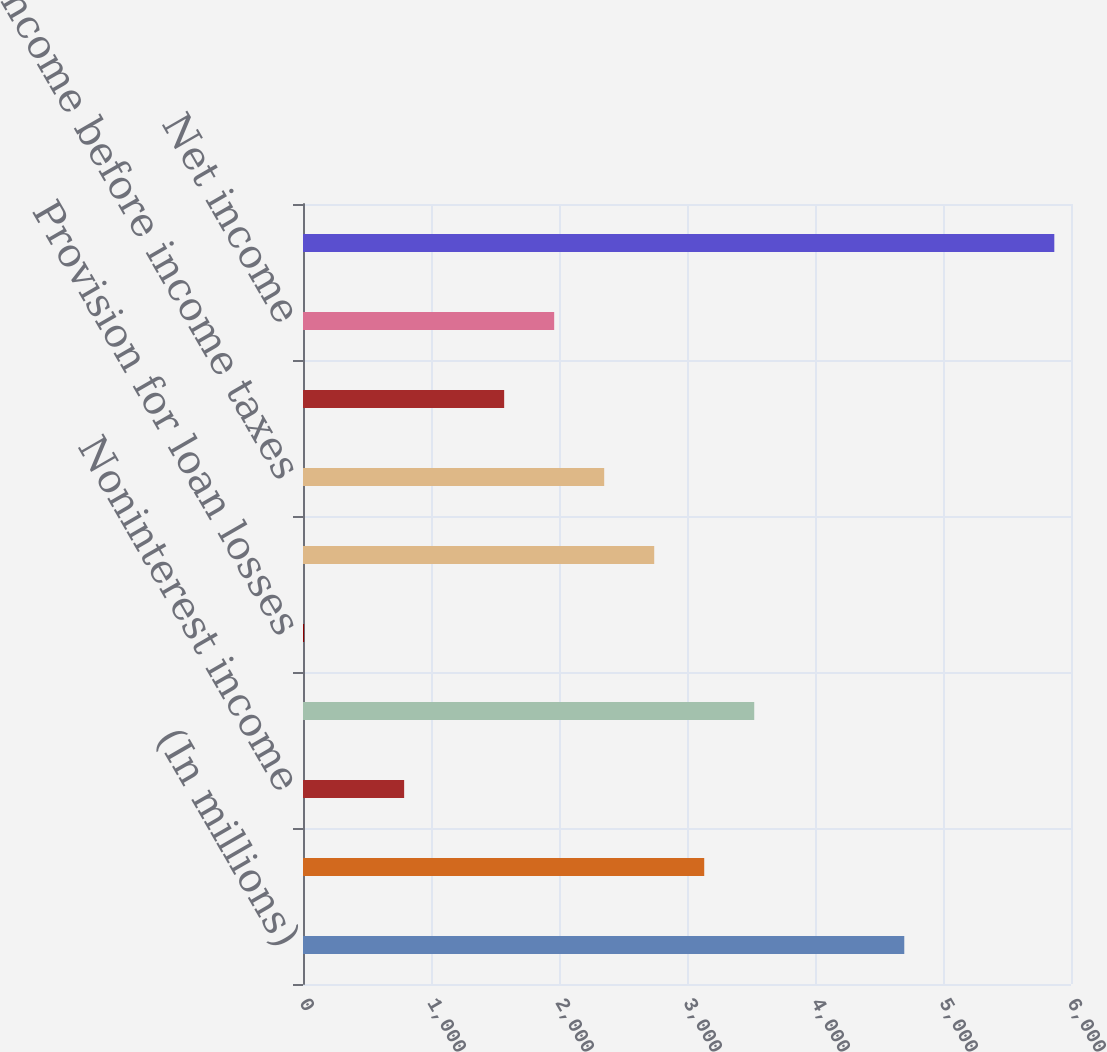Convert chart to OTSL. <chart><loc_0><loc_0><loc_500><loc_500><bar_chart><fcel>(In millions)<fcel>Net interest income<fcel>Noninterest income<fcel>Total revenue<fcel>Provision for loan losses<fcel>Noninterest expense<fcel>Income before income taxes<fcel>Income tax expense<fcel>Net income<fcel>Total assets<nl><fcel>4697.46<fcel>3134.54<fcel>790.16<fcel>3525.27<fcel>8.7<fcel>2743.81<fcel>2353.08<fcel>1571.62<fcel>1962.35<fcel>5869.65<nl></chart> 